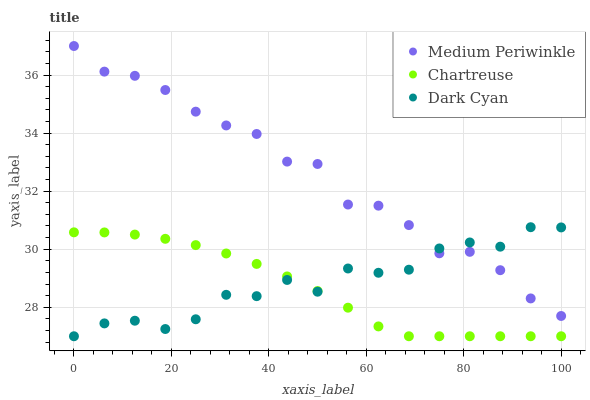Does Chartreuse have the minimum area under the curve?
Answer yes or no. Yes. Does Medium Periwinkle have the maximum area under the curve?
Answer yes or no. Yes. Does Medium Periwinkle have the minimum area under the curve?
Answer yes or no. No. Does Chartreuse have the maximum area under the curve?
Answer yes or no. No. Is Chartreuse the smoothest?
Answer yes or no. Yes. Is Dark Cyan the roughest?
Answer yes or no. Yes. Is Medium Periwinkle the smoothest?
Answer yes or no. No. Is Medium Periwinkle the roughest?
Answer yes or no. No. Does Dark Cyan have the lowest value?
Answer yes or no. Yes. Does Medium Periwinkle have the lowest value?
Answer yes or no. No. Does Medium Periwinkle have the highest value?
Answer yes or no. Yes. Does Chartreuse have the highest value?
Answer yes or no. No. Is Chartreuse less than Medium Periwinkle?
Answer yes or no. Yes. Is Medium Periwinkle greater than Chartreuse?
Answer yes or no. Yes. Does Chartreuse intersect Dark Cyan?
Answer yes or no. Yes. Is Chartreuse less than Dark Cyan?
Answer yes or no. No. Is Chartreuse greater than Dark Cyan?
Answer yes or no. No. Does Chartreuse intersect Medium Periwinkle?
Answer yes or no. No. 